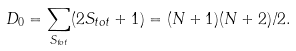<formula> <loc_0><loc_0><loc_500><loc_500>D _ { 0 } = \sum _ { S _ { t o t } } ( 2 S _ { t o t } + 1 ) = ( N + 1 ) ( N + 2 ) / 2 .</formula> 